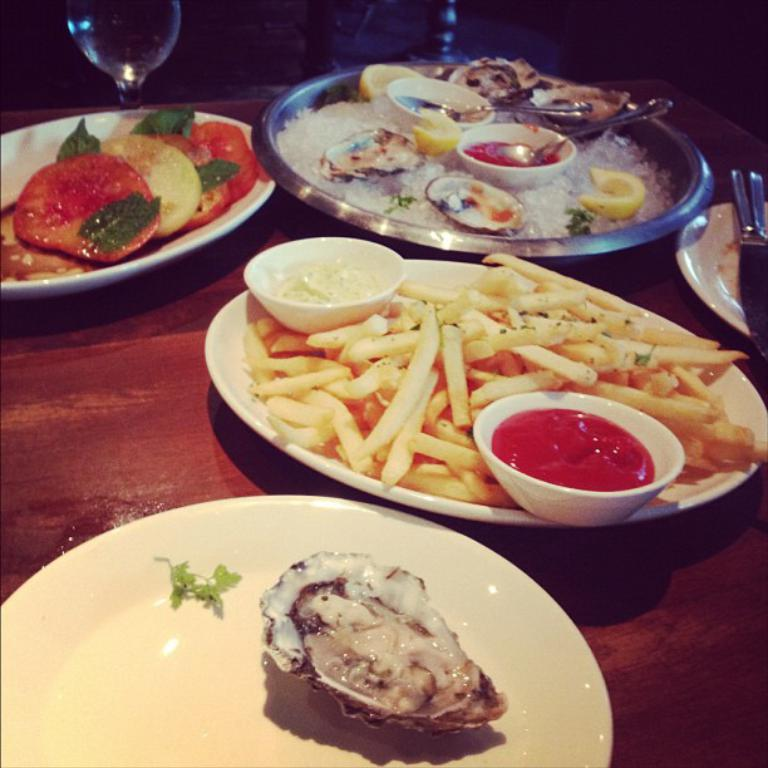What piece of furniture is present in the image? There is a table in the image. What is placed on the table? There are plates and glass items on the table. What is in the plates? There are food items in the plates. What utensils are visible in the image? Forks are visible in the image. What type of property is being designed in the image? There is no indication of any property or design work in the image; it features a table with plates, glass items, food items, and forks. 